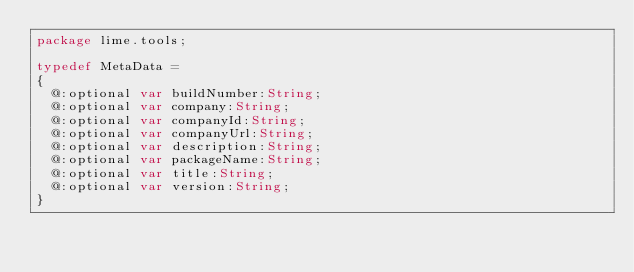Convert code to text. <code><loc_0><loc_0><loc_500><loc_500><_Haxe_>package lime.tools;

typedef MetaData =
{
	@:optional var buildNumber:String;
	@:optional var company:String;
	@:optional var companyId:String;
	@:optional var companyUrl:String;
	@:optional var description:String;
	@:optional var packageName:String;
	@:optional var title:String;
	@:optional var version:String;
}
</code> 